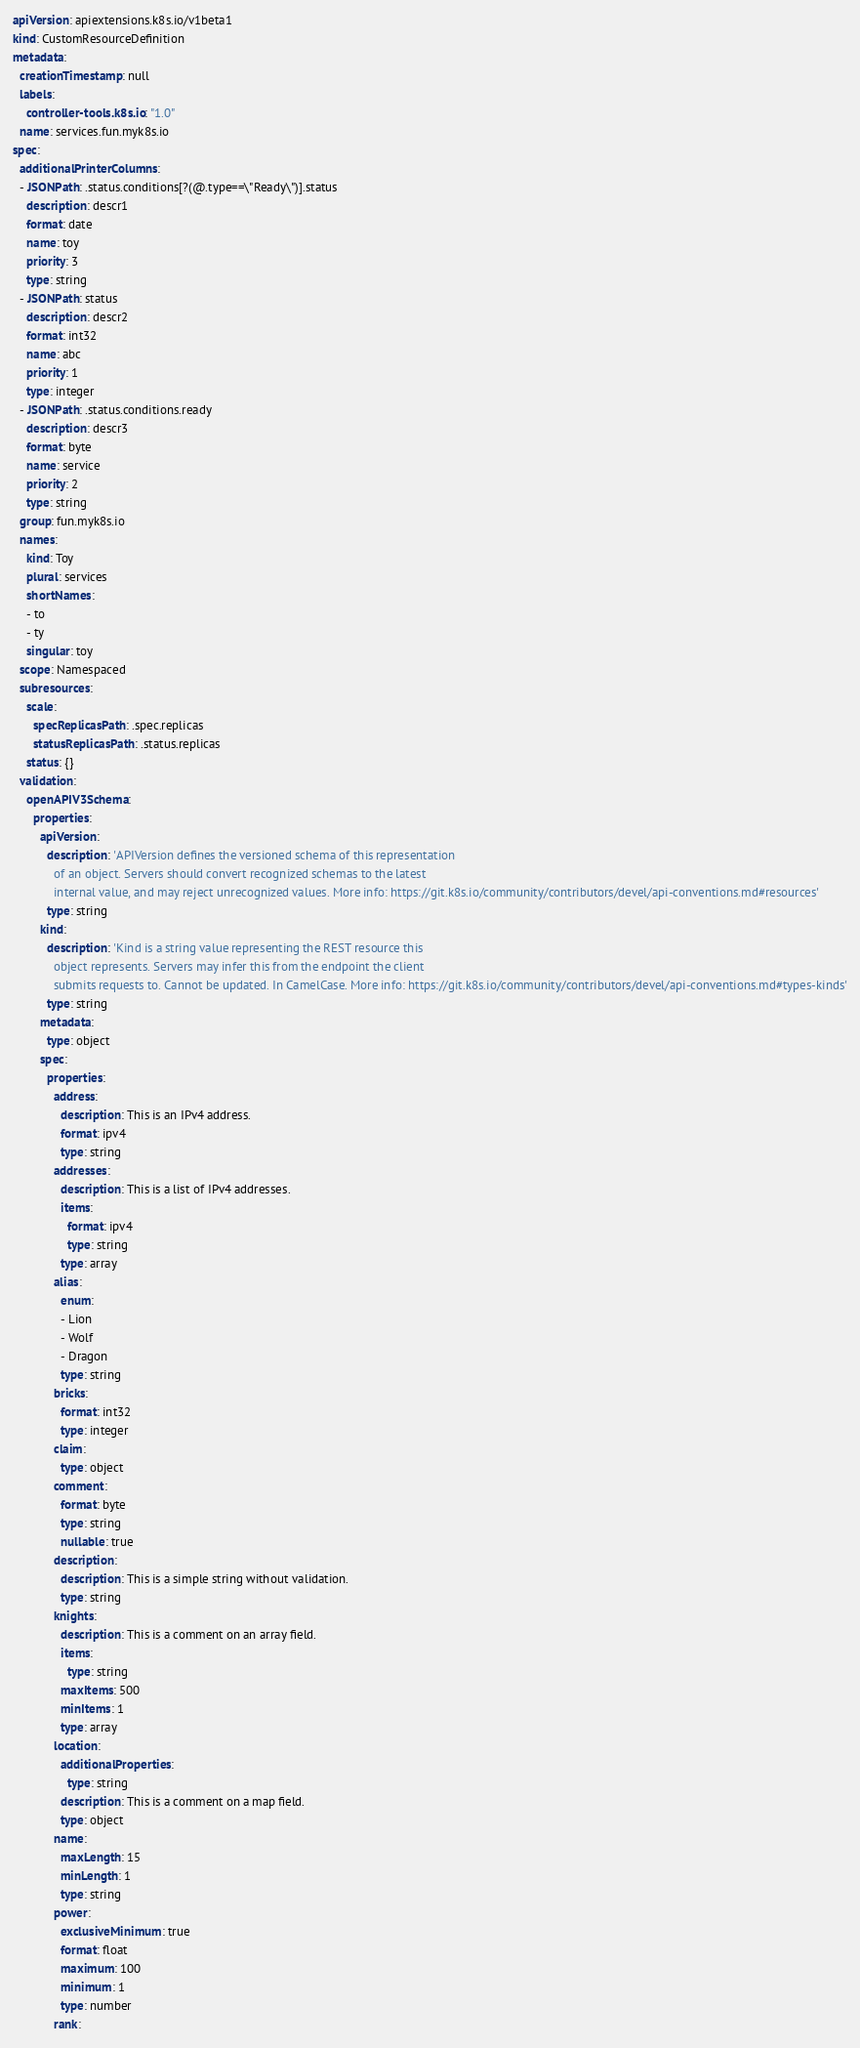Convert code to text. <code><loc_0><loc_0><loc_500><loc_500><_YAML_>apiVersion: apiextensions.k8s.io/v1beta1
kind: CustomResourceDefinition
metadata:
  creationTimestamp: null
  labels:
    controller-tools.k8s.io: "1.0"
  name: services.fun.myk8s.io
spec:
  additionalPrinterColumns:
  - JSONPath: .status.conditions[?(@.type==\"Ready\")].status
    description: descr1
    format: date
    name: toy
    priority: 3
    type: string
  - JSONPath: status
    description: descr2
    format: int32
    name: abc
    priority: 1
    type: integer
  - JSONPath: .status.conditions.ready
    description: descr3
    format: byte
    name: service
    priority: 2
    type: string
  group: fun.myk8s.io
  names:
    kind: Toy
    plural: services
    shortNames:
    - to
    - ty
    singular: toy
  scope: Namespaced
  subresources:
    scale:
      specReplicasPath: .spec.replicas
      statusReplicasPath: .status.replicas
    status: {}
  validation:
    openAPIV3Schema:
      properties:
        apiVersion:
          description: 'APIVersion defines the versioned schema of this representation
            of an object. Servers should convert recognized schemas to the latest
            internal value, and may reject unrecognized values. More info: https://git.k8s.io/community/contributors/devel/api-conventions.md#resources'
          type: string
        kind:
          description: 'Kind is a string value representing the REST resource this
            object represents. Servers may infer this from the endpoint the client
            submits requests to. Cannot be updated. In CamelCase. More info: https://git.k8s.io/community/contributors/devel/api-conventions.md#types-kinds'
          type: string
        metadata:
          type: object
        spec:
          properties:
            address:
              description: This is an IPv4 address.
              format: ipv4
              type: string
            addresses:
              description: This is a list of IPv4 addresses.
              items:
                format: ipv4
                type: string
              type: array
            alias:
              enum:
              - Lion
              - Wolf
              - Dragon
              type: string
            bricks:
              format: int32
              type: integer
            claim:
              type: object
            comment:
              format: byte
              type: string
              nullable: true
            description:
              description: This is a simple string without validation.
              type: string
            knights:
              description: This is a comment on an array field.
              items:
                type: string
              maxItems: 500
              minItems: 1
              type: array
            location:
              additionalProperties:
                type: string
              description: This is a comment on a map field.
              type: object
            name:
              maxLength: 15
              minLength: 1
              type: string
            power:
              exclusiveMinimum: true
              format: float
              maximum: 100
              minimum: 1
              type: number
            rank:</code> 